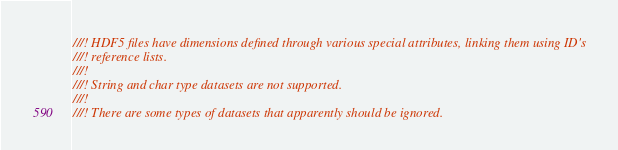Convert code to text. <code><loc_0><loc_0><loc_500><loc_500><_Rust_>///! HDF5 files have dimensions defined through various special attributes, linking them using ID's
///! reference lists.
///!
///! String and char type datasets are not supported.
///!
///! There are some types of datasets that apparently should be ignored.</code> 